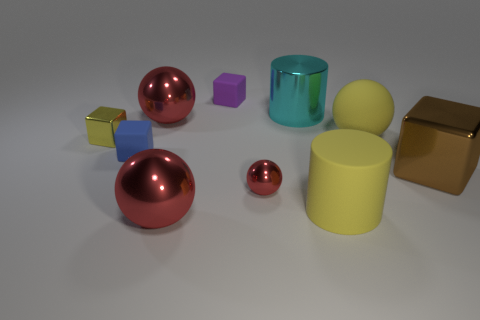Is the red sphere behind the small metal block made of the same material as the small yellow cube? While the image is a rendering and the materials are simulated, the red sphere behind the small metal block appears to have a reflective surface akin to metal, similar in texture and sheen to the small yellow cube. Therefore, based on the visual properties exhibited in the image, one could infer that they are indeed meant to represent the same type of material, likely a type of polished metal. 